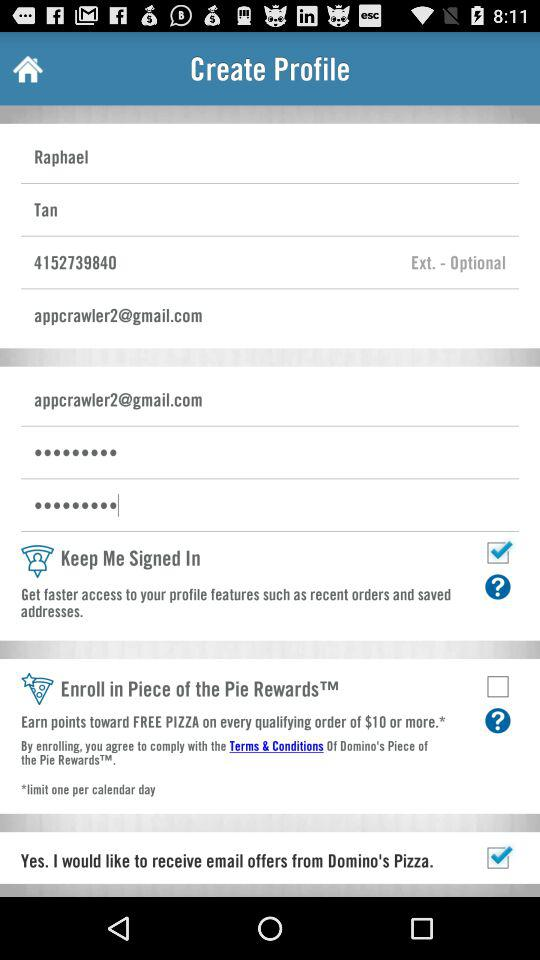What's the email address? The email address is appcrawler2@gmail.com. 